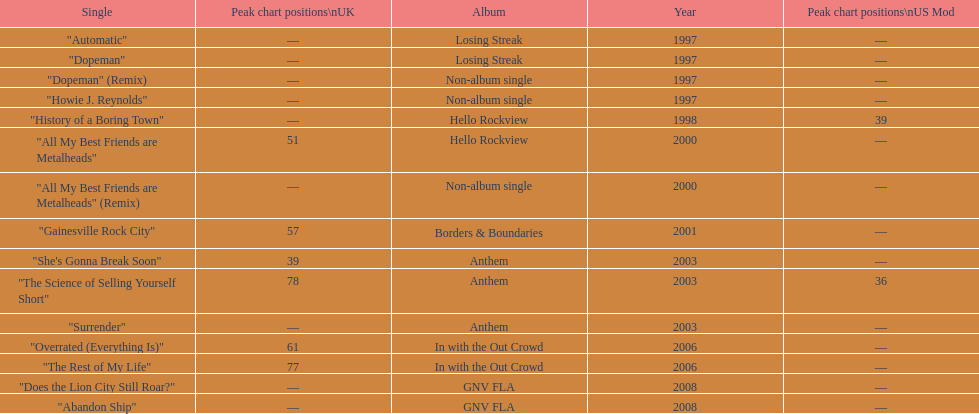Which album had the single automatic? Losing Streak. Could you parse the entire table as a dict? {'header': ['Single', 'Peak chart positions\\nUK', 'Album', 'Year', 'Peak chart positions\\nUS Mod'], 'rows': [['"Automatic"', '—', 'Losing Streak', '1997', '—'], ['"Dopeman"', '—', 'Losing Streak', '1997', '—'], ['"Dopeman" (Remix)', '—', 'Non-album single', '1997', '—'], ['"Howie J. Reynolds"', '—', 'Non-album single', '1997', '—'], ['"History of a Boring Town"', '—', 'Hello Rockview', '1998', '39'], ['"All My Best Friends are Metalheads"', '51', 'Hello Rockview', '2000', '—'], ['"All My Best Friends are Metalheads" (Remix)', '—', 'Non-album single', '2000', '—'], ['"Gainesville Rock City"', '57', 'Borders & Boundaries', '2001', '—'], ['"She\'s Gonna Break Soon"', '39', 'Anthem', '2003', '—'], ['"The Science of Selling Yourself Short"', '78', 'Anthem', '2003', '36'], ['"Surrender"', '—', 'Anthem', '2003', '—'], ['"Overrated (Everything Is)"', '61', 'In with the Out Crowd', '2006', '—'], ['"The Rest of My Life"', '77', 'In with the Out Crowd', '2006', '—'], ['"Does the Lion City Still Roar?"', '—', 'GNV FLA', '2008', '—'], ['"Abandon Ship"', '—', 'GNV FLA', '2008', '—']]} 